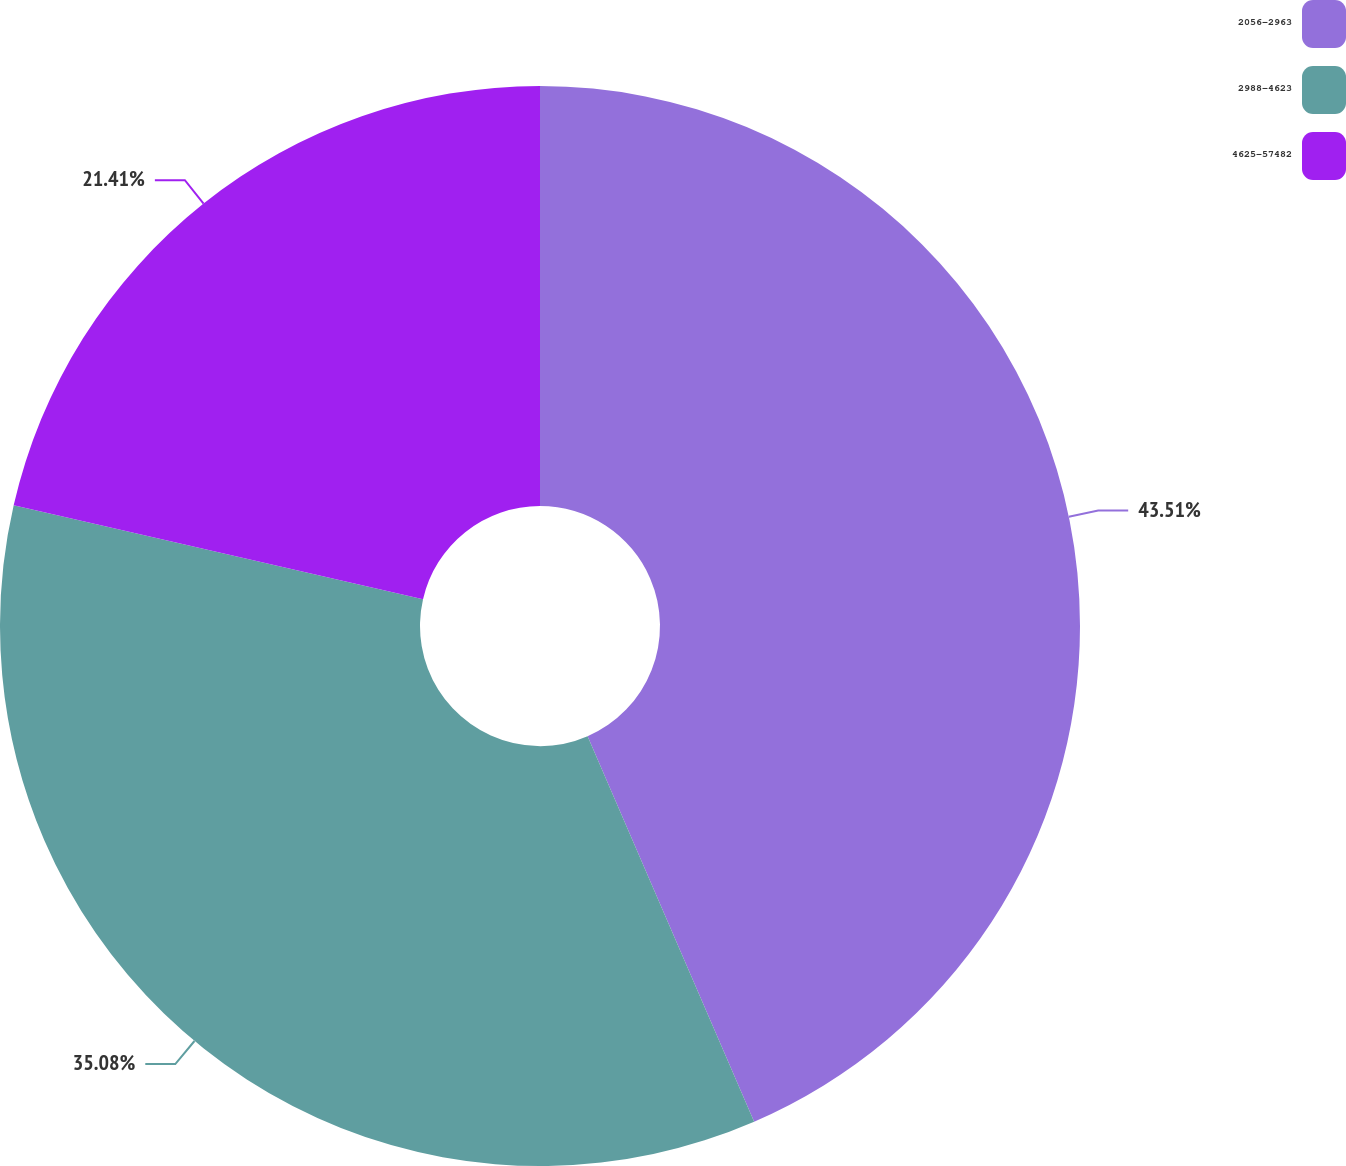Convert chart. <chart><loc_0><loc_0><loc_500><loc_500><pie_chart><fcel>2056-2963<fcel>2988-4623<fcel>4625-57482<nl><fcel>43.51%<fcel>35.08%<fcel>21.41%<nl></chart> 